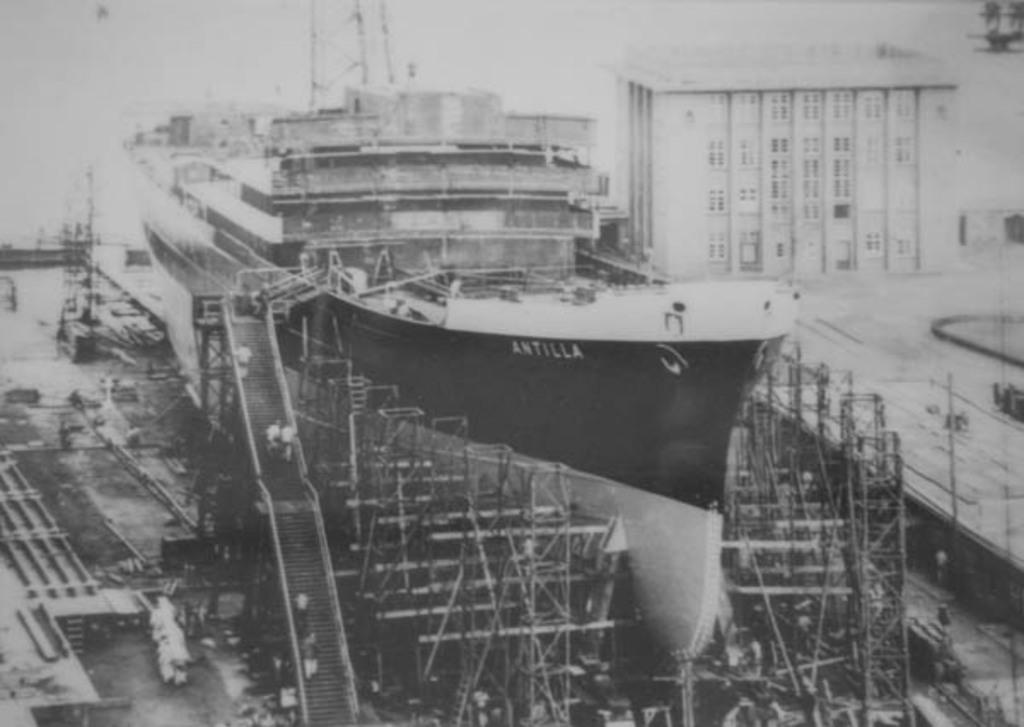What is the name on the ship?
Provide a short and direct response. Antilla. 